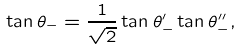Convert formula to latex. <formula><loc_0><loc_0><loc_500><loc_500>\tan \theta _ { - } = \frac { 1 } { \sqrt { 2 } } \tan \theta _ { - } ^ { \prime } \tan \theta _ { - } ^ { \prime \prime } ,</formula> 